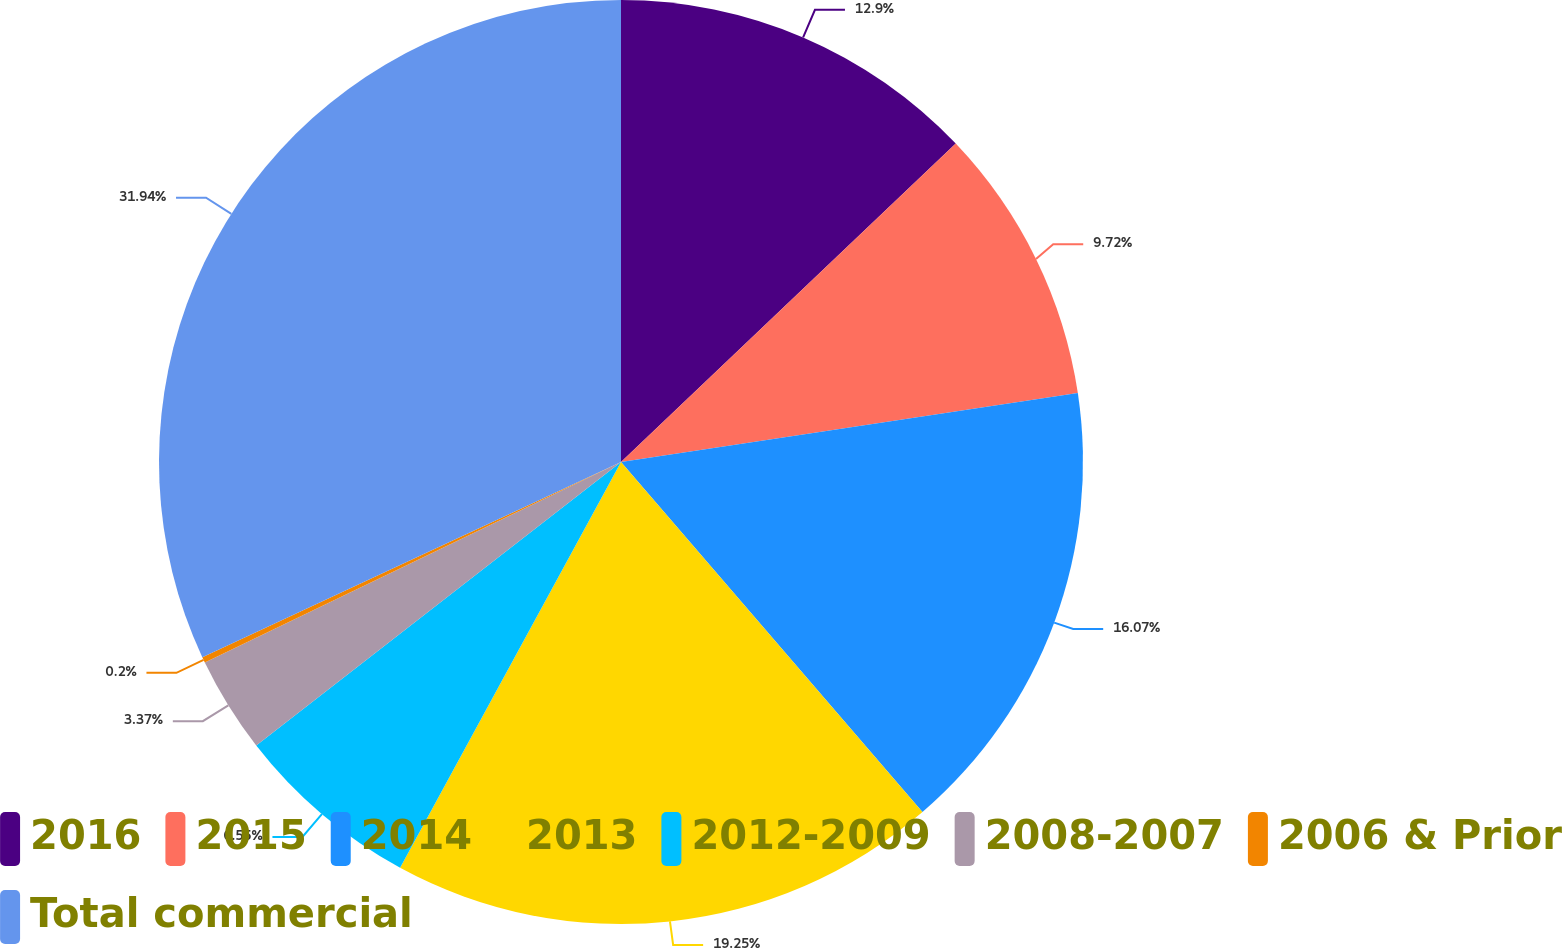Convert chart to OTSL. <chart><loc_0><loc_0><loc_500><loc_500><pie_chart><fcel>2016<fcel>2015<fcel>2014<fcel>2013<fcel>2012-2009<fcel>2008-2007<fcel>2006 & Prior<fcel>Total commercial<nl><fcel>12.9%<fcel>9.72%<fcel>16.07%<fcel>19.25%<fcel>6.55%<fcel>3.37%<fcel>0.2%<fcel>31.95%<nl></chart> 